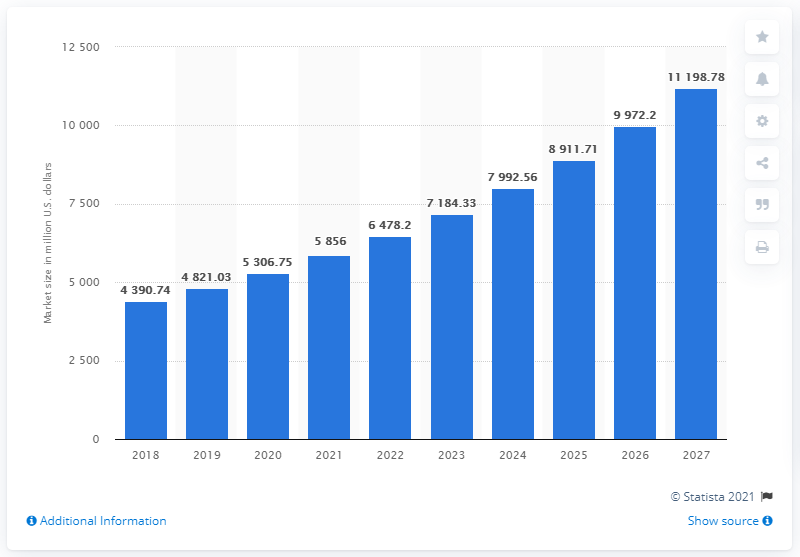List a handful of essential elements in this visual. In 2018, the global high-flow nasal cannula market was valued at approximately 4,390.74 dollars. The global high-flow nasal cannula market is expected to reach 11.2 billion dollars by the year 2027. 